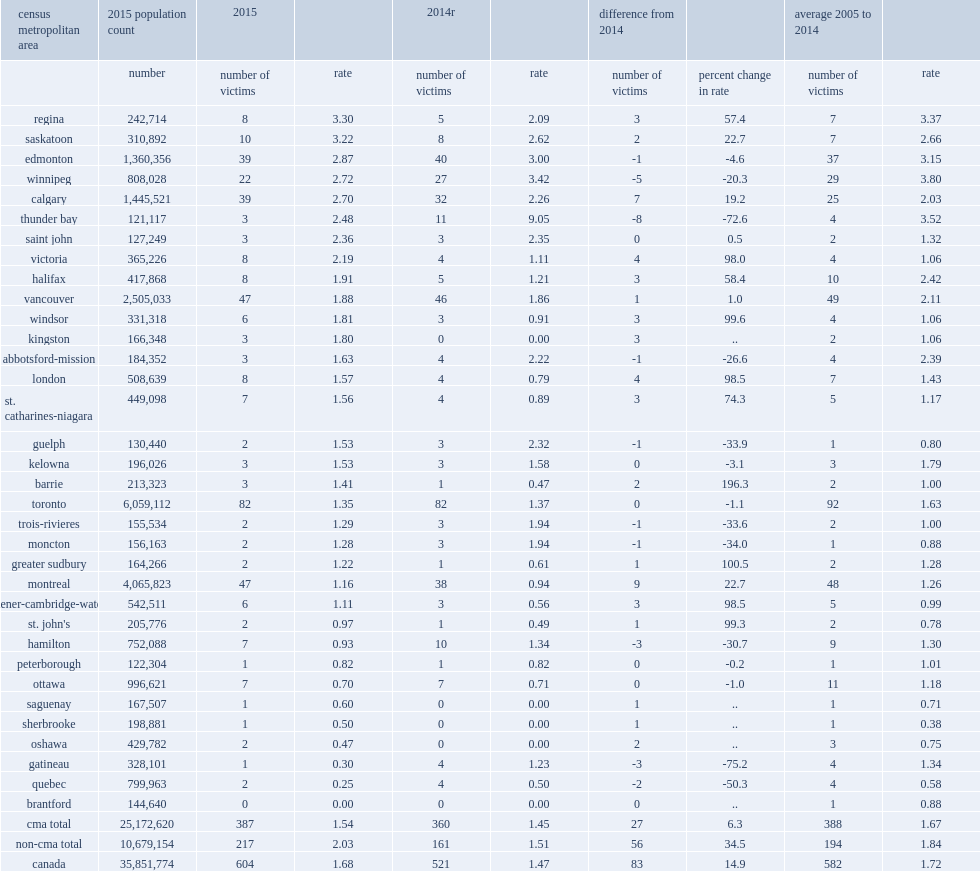Which cma recorded the highest homicide rate among the 33 cmas in 2015? Regina. List the two cmas that recorded the second and third highest homicide rates in 2015 respectively. Saskatoon edmonton. Which cma reported no homicides in 2015. Brantford. 